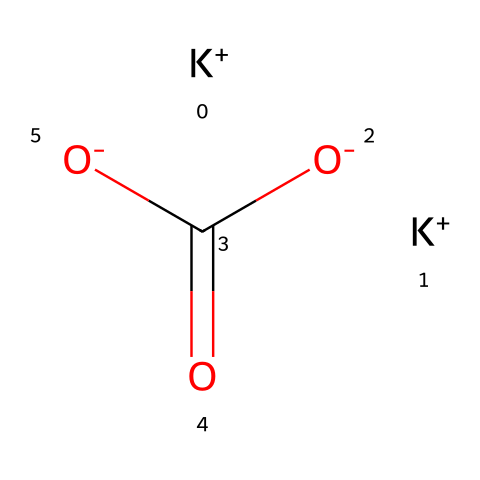What is the molecular formula of this compound? By interpreting the SMILES notation, we identify the components: There are 2 potassium atoms (K), 1 carbon atom (C), and 4 oxygen atoms (O). Putting these together gives the molecular formula K2CO3.
Answer: K2CO3 How many potassium ions are in the structure? The SMILES shows [K+] two times, which indicates there are two potassium ions present.
Answer: 2 What type of compound is potassium carbonate? The presence of potassium ions, and carbonate group (C(=O)[O-]) suggests it is a salt or base, specifically categorized as an inorganic base.
Answer: base Which part of the compound contributes to its basicity? The carbonate portion of the molecule (C(=O)[O-]) contains negatively charged oxygen atoms, which can accept protons, contributing to its basic nature.
Answer: carbonate How many total atoms are present in the molecule? Counting the atoms: 2 potassium (K), 1 carbon (C), and 4 oxygen (O) gives a total of 7 atoms in the molecule.
Answer: 7 What role does potassium carbonate play in fire extinguishers? Potassium carbonate helps by producing carbon dioxide when heated, depriving the fire of oxygen, which is crucial for combustion.
Answer: extinguishing What is the charge of the carbonate anion in this compound? The carbonate anion (CO3) is represented by the two negative charges [O-] in the SMILES, indicating a -2 charge overall for the anion.
Answer: -2 